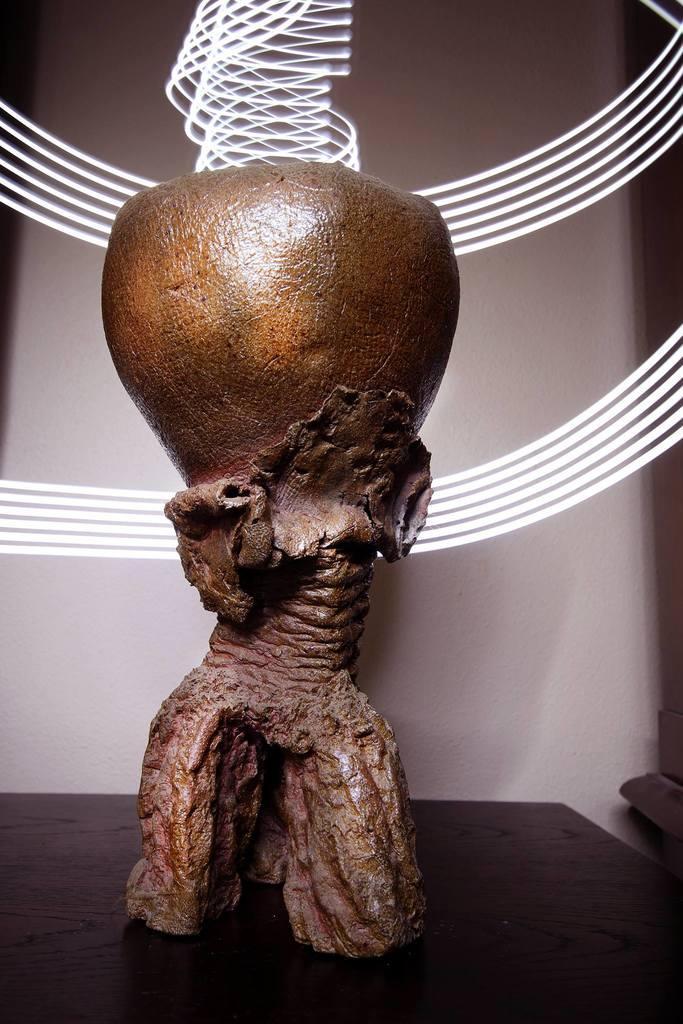Can you describe this image briefly? In this image we can see a carved object. 